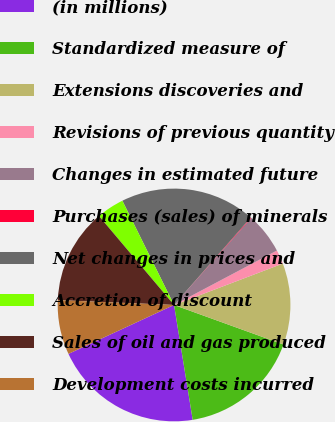Convert chart. <chart><loc_0><loc_0><loc_500><loc_500><pie_chart><fcel>(in millions)<fcel>Standardized measure of<fcel>Extensions discoveries and<fcel>Revisions of previous quantity<fcel>Changes in estimated future<fcel>Purchases (sales) of minerals<fcel>Net changes in prices and<fcel>Accretion of discount<fcel>Sales of oil and gas produced<fcel>Development costs incurred<nl><fcel>20.66%<fcel>16.92%<fcel>11.31%<fcel>1.96%<fcel>5.7%<fcel>0.09%<fcel>18.79%<fcel>3.83%<fcel>13.18%<fcel>7.57%<nl></chart> 